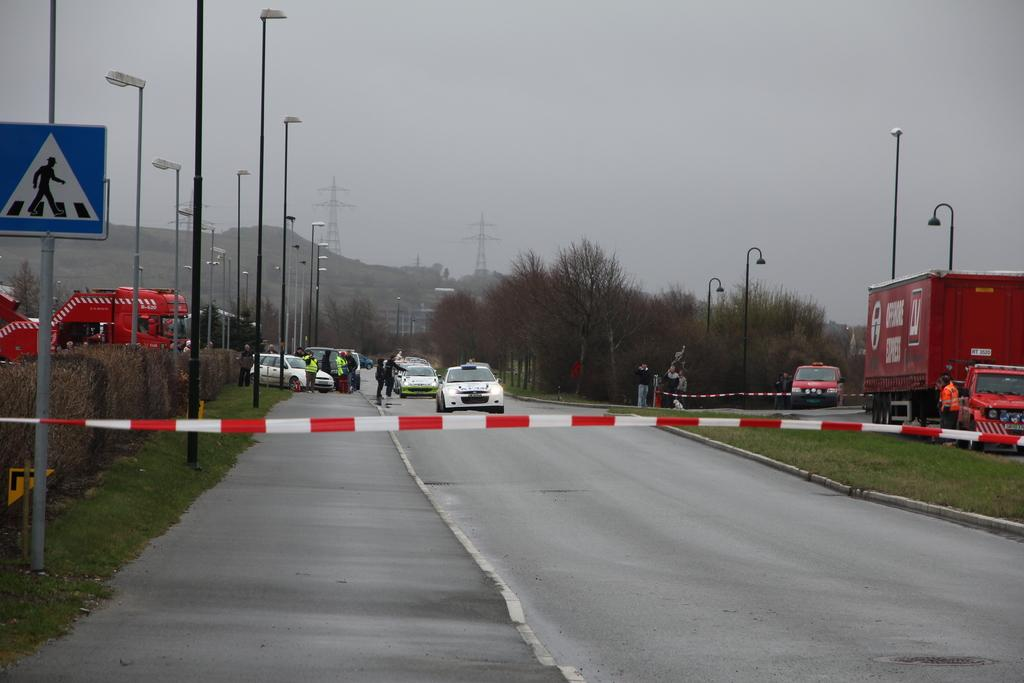What type of barrier can be seen in the image? There are caution tapes in the image. What types of vehicles are present in the image? There are vehicles in the image. What kind of vegetation can be seen in the image? There are plants and trees in the image. What structures are present in the image? There are poles in the image. How many people are visible in the image? There are people in the image. What type of signage is present in the image? There are sign boards in the image. What type of ground surface is visible in the image? There is grass in the image. What type of transportation infrastructure is present in the image? There are roads in the image. What type of natural landscape is visible in the background of the image? The background of the image includes hills. What type of tall structures are visible in the background of the image? Transmission towers are visible in the background. What part of the natural environment is visible in the background of the image? The sky is visible in the background. Where is the faucet located in the image? There is no faucet present in the image. What type of hope can be seen in the image? There is no reference to hope in the image; it features caution tapes, vehicles, plants, trees, poles, people, sign boards, grass, roads, hills, transmission towers, and the sky. 